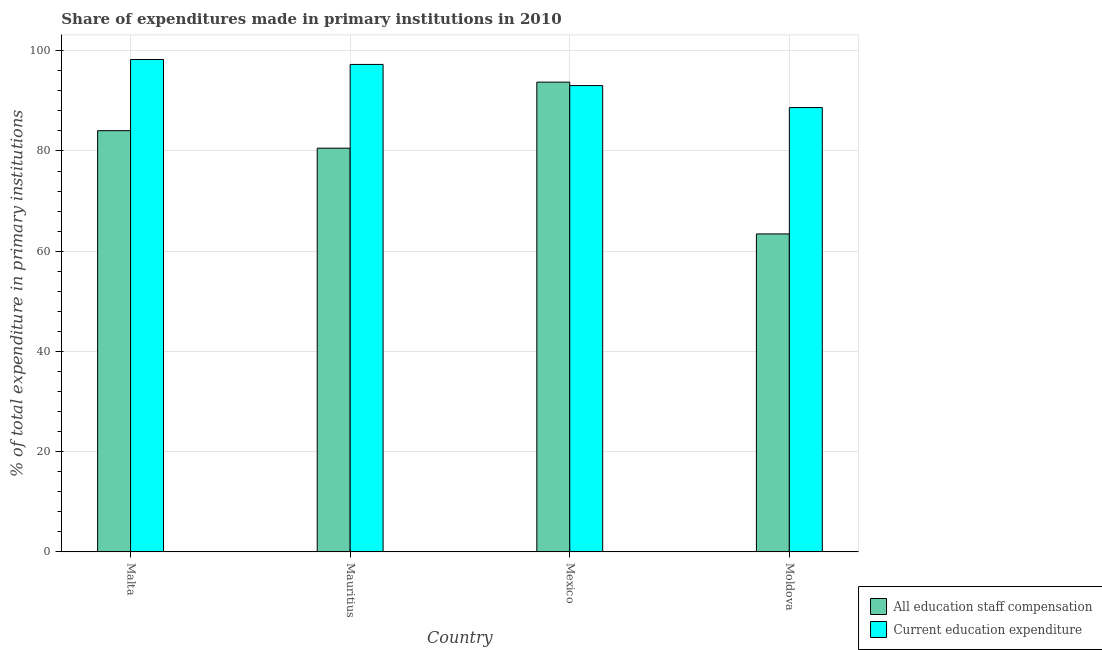How many different coloured bars are there?
Your response must be concise. 2. Are the number of bars per tick equal to the number of legend labels?
Keep it short and to the point. Yes. Are the number of bars on each tick of the X-axis equal?
Make the answer very short. Yes. How many bars are there on the 3rd tick from the left?
Provide a succinct answer. 2. How many bars are there on the 4th tick from the right?
Your answer should be very brief. 2. What is the label of the 3rd group of bars from the left?
Keep it short and to the point. Mexico. In how many cases, is the number of bars for a given country not equal to the number of legend labels?
Keep it short and to the point. 0. What is the expenditure in education in Mexico?
Your answer should be compact. 93.05. Across all countries, what is the maximum expenditure in education?
Provide a succinct answer. 98.25. Across all countries, what is the minimum expenditure in education?
Make the answer very short. 88.66. In which country was the expenditure in education maximum?
Keep it short and to the point. Malta. In which country was the expenditure in staff compensation minimum?
Provide a short and direct response. Moldova. What is the total expenditure in education in the graph?
Provide a succinct answer. 377.22. What is the difference between the expenditure in staff compensation in Mauritius and that in Mexico?
Your answer should be very brief. -13.18. What is the difference between the expenditure in staff compensation in Moldova and the expenditure in education in Mauritius?
Give a very brief answer. -33.82. What is the average expenditure in education per country?
Make the answer very short. 94.3. What is the difference between the expenditure in staff compensation and expenditure in education in Moldova?
Provide a succinct answer. -25.21. What is the ratio of the expenditure in education in Malta to that in Mauritius?
Ensure brevity in your answer.  1.01. What is the difference between the highest and the second highest expenditure in education?
Ensure brevity in your answer.  0.99. What is the difference between the highest and the lowest expenditure in staff compensation?
Give a very brief answer. 30.28. What does the 2nd bar from the left in Moldova represents?
Give a very brief answer. Current education expenditure. What does the 2nd bar from the right in Mexico represents?
Your answer should be very brief. All education staff compensation. How many bars are there?
Keep it short and to the point. 8. Are all the bars in the graph horizontal?
Provide a succinct answer. No. How many countries are there in the graph?
Keep it short and to the point. 4. What is the difference between two consecutive major ticks on the Y-axis?
Give a very brief answer. 20. Are the values on the major ticks of Y-axis written in scientific E-notation?
Offer a terse response. No. Does the graph contain grids?
Make the answer very short. Yes. Where does the legend appear in the graph?
Offer a terse response. Bottom right. How many legend labels are there?
Your answer should be very brief. 2. How are the legend labels stacked?
Your answer should be very brief. Vertical. What is the title of the graph?
Offer a terse response. Share of expenditures made in primary institutions in 2010. Does "Tetanus" appear as one of the legend labels in the graph?
Make the answer very short. No. What is the label or title of the X-axis?
Your answer should be compact. Country. What is the label or title of the Y-axis?
Your answer should be compact. % of total expenditure in primary institutions. What is the % of total expenditure in primary institutions in All education staff compensation in Malta?
Keep it short and to the point. 84.05. What is the % of total expenditure in primary institutions of Current education expenditure in Malta?
Offer a terse response. 98.25. What is the % of total expenditure in primary institutions of All education staff compensation in Mauritius?
Your answer should be very brief. 80.56. What is the % of total expenditure in primary institutions of Current education expenditure in Mauritius?
Offer a terse response. 97.26. What is the % of total expenditure in primary institutions in All education staff compensation in Mexico?
Offer a very short reply. 93.73. What is the % of total expenditure in primary institutions of Current education expenditure in Mexico?
Make the answer very short. 93.05. What is the % of total expenditure in primary institutions of All education staff compensation in Moldova?
Offer a very short reply. 63.45. What is the % of total expenditure in primary institutions of Current education expenditure in Moldova?
Give a very brief answer. 88.66. Across all countries, what is the maximum % of total expenditure in primary institutions of All education staff compensation?
Provide a succinct answer. 93.73. Across all countries, what is the maximum % of total expenditure in primary institutions in Current education expenditure?
Provide a short and direct response. 98.25. Across all countries, what is the minimum % of total expenditure in primary institutions in All education staff compensation?
Give a very brief answer. 63.45. Across all countries, what is the minimum % of total expenditure in primary institutions in Current education expenditure?
Make the answer very short. 88.66. What is the total % of total expenditure in primary institutions in All education staff compensation in the graph?
Give a very brief answer. 321.78. What is the total % of total expenditure in primary institutions in Current education expenditure in the graph?
Your answer should be very brief. 377.22. What is the difference between the % of total expenditure in primary institutions in All education staff compensation in Malta and that in Mauritius?
Offer a very short reply. 3.49. What is the difference between the % of total expenditure in primary institutions in Current education expenditure in Malta and that in Mauritius?
Make the answer very short. 0.99. What is the difference between the % of total expenditure in primary institutions in All education staff compensation in Malta and that in Mexico?
Provide a short and direct response. -9.68. What is the difference between the % of total expenditure in primary institutions in Current education expenditure in Malta and that in Mexico?
Provide a short and direct response. 5.2. What is the difference between the % of total expenditure in primary institutions in All education staff compensation in Malta and that in Moldova?
Your response must be concise. 20.6. What is the difference between the % of total expenditure in primary institutions in Current education expenditure in Malta and that in Moldova?
Provide a short and direct response. 9.59. What is the difference between the % of total expenditure in primary institutions of All education staff compensation in Mauritius and that in Mexico?
Provide a succinct answer. -13.18. What is the difference between the % of total expenditure in primary institutions in Current education expenditure in Mauritius and that in Mexico?
Ensure brevity in your answer.  4.22. What is the difference between the % of total expenditure in primary institutions of All education staff compensation in Mauritius and that in Moldova?
Make the answer very short. 17.11. What is the difference between the % of total expenditure in primary institutions in Current education expenditure in Mauritius and that in Moldova?
Provide a succinct answer. 8.6. What is the difference between the % of total expenditure in primary institutions in All education staff compensation in Mexico and that in Moldova?
Give a very brief answer. 30.28. What is the difference between the % of total expenditure in primary institutions in Current education expenditure in Mexico and that in Moldova?
Provide a short and direct response. 4.39. What is the difference between the % of total expenditure in primary institutions in All education staff compensation in Malta and the % of total expenditure in primary institutions in Current education expenditure in Mauritius?
Make the answer very short. -13.22. What is the difference between the % of total expenditure in primary institutions of All education staff compensation in Malta and the % of total expenditure in primary institutions of Current education expenditure in Mexico?
Keep it short and to the point. -9. What is the difference between the % of total expenditure in primary institutions of All education staff compensation in Malta and the % of total expenditure in primary institutions of Current education expenditure in Moldova?
Your answer should be compact. -4.61. What is the difference between the % of total expenditure in primary institutions of All education staff compensation in Mauritius and the % of total expenditure in primary institutions of Current education expenditure in Mexico?
Give a very brief answer. -12.49. What is the difference between the % of total expenditure in primary institutions in All education staff compensation in Mauritius and the % of total expenditure in primary institutions in Current education expenditure in Moldova?
Keep it short and to the point. -8.11. What is the difference between the % of total expenditure in primary institutions in All education staff compensation in Mexico and the % of total expenditure in primary institutions in Current education expenditure in Moldova?
Your answer should be compact. 5.07. What is the average % of total expenditure in primary institutions of All education staff compensation per country?
Your answer should be compact. 80.45. What is the average % of total expenditure in primary institutions in Current education expenditure per country?
Make the answer very short. 94.3. What is the difference between the % of total expenditure in primary institutions of All education staff compensation and % of total expenditure in primary institutions of Current education expenditure in Malta?
Keep it short and to the point. -14.2. What is the difference between the % of total expenditure in primary institutions of All education staff compensation and % of total expenditure in primary institutions of Current education expenditure in Mauritius?
Provide a short and direct response. -16.71. What is the difference between the % of total expenditure in primary institutions of All education staff compensation and % of total expenditure in primary institutions of Current education expenditure in Mexico?
Ensure brevity in your answer.  0.68. What is the difference between the % of total expenditure in primary institutions in All education staff compensation and % of total expenditure in primary institutions in Current education expenditure in Moldova?
Give a very brief answer. -25.21. What is the ratio of the % of total expenditure in primary institutions in All education staff compensation in Malta to that in Mauritius?
Provide a succinct answer. 1.04. What is the ratio of the % of total expenditure in primary institutions of All education staff compensation in Malta to that in Mexico?
Provide a short and direct response. 0.9. What is the ratio of the % of total expenditure in primary institutions in Current education expenditure in Malta to that in Mexico?
Make the answer very short. 1.06. What is the ratio of the % of total expenditure in primary institutions of All education staff compensation in Malta to that in Moldova?
Keep it short and to the point. 1.32. What is the ratio of the % of total expenditure in primary institutions in Current education expenditure in Malta to that in Moldova?
Offer a terse response. 1.11. What is the ratio of the % of total expenditure in primary institutions of All education staff compensation in Mauritius to that in Mexico?
Your response must be concise. 0.86. What is the ratio of the % of total expenditure in primary institutions in Current education expenditure in Mauritius to that in Mexico?
Your response must be concise. 1.05. What is the ratio of the % of total expenditure in primary institutions of All education staff compensation in Mauritius to that in Moldova?
Keep it short and to the point. 1.27. What is the ratio of the % of total expenditure in primary institutions of Current education expenditure in Mauritius to that in Moldova?
Provide a succinct answer. 1.1. What is the ratio of the % of total expenditure in primary institutions of All education staff compensation in Mexico to that in Moldova?
Provide a short and direct response. 1.48. What is the ratio of the % of total expenditure in primary institutions in Current education expenditure in Mexico to that in Moldova?
Your response must be concise. 1.05. What is the difference between the highest and the second highest % of total expenditure in primary institutions of All education staff compensation?
Provide a short and direct response. 9.68. What is the difference between the highest and the second highest % of total expenditure in primary institutions of Current education expenditure?
Give a very brief answer. 0.99. What is the difference between the highest and the lowest % of total expenditure in primary institutions of All education staff compensation?
Offer a very short reply. 30.28. What is the difference between the highest and the lowest % of total expenditure in primary institutions of Current education expenditure?
Make the answer very short. 9.59. 